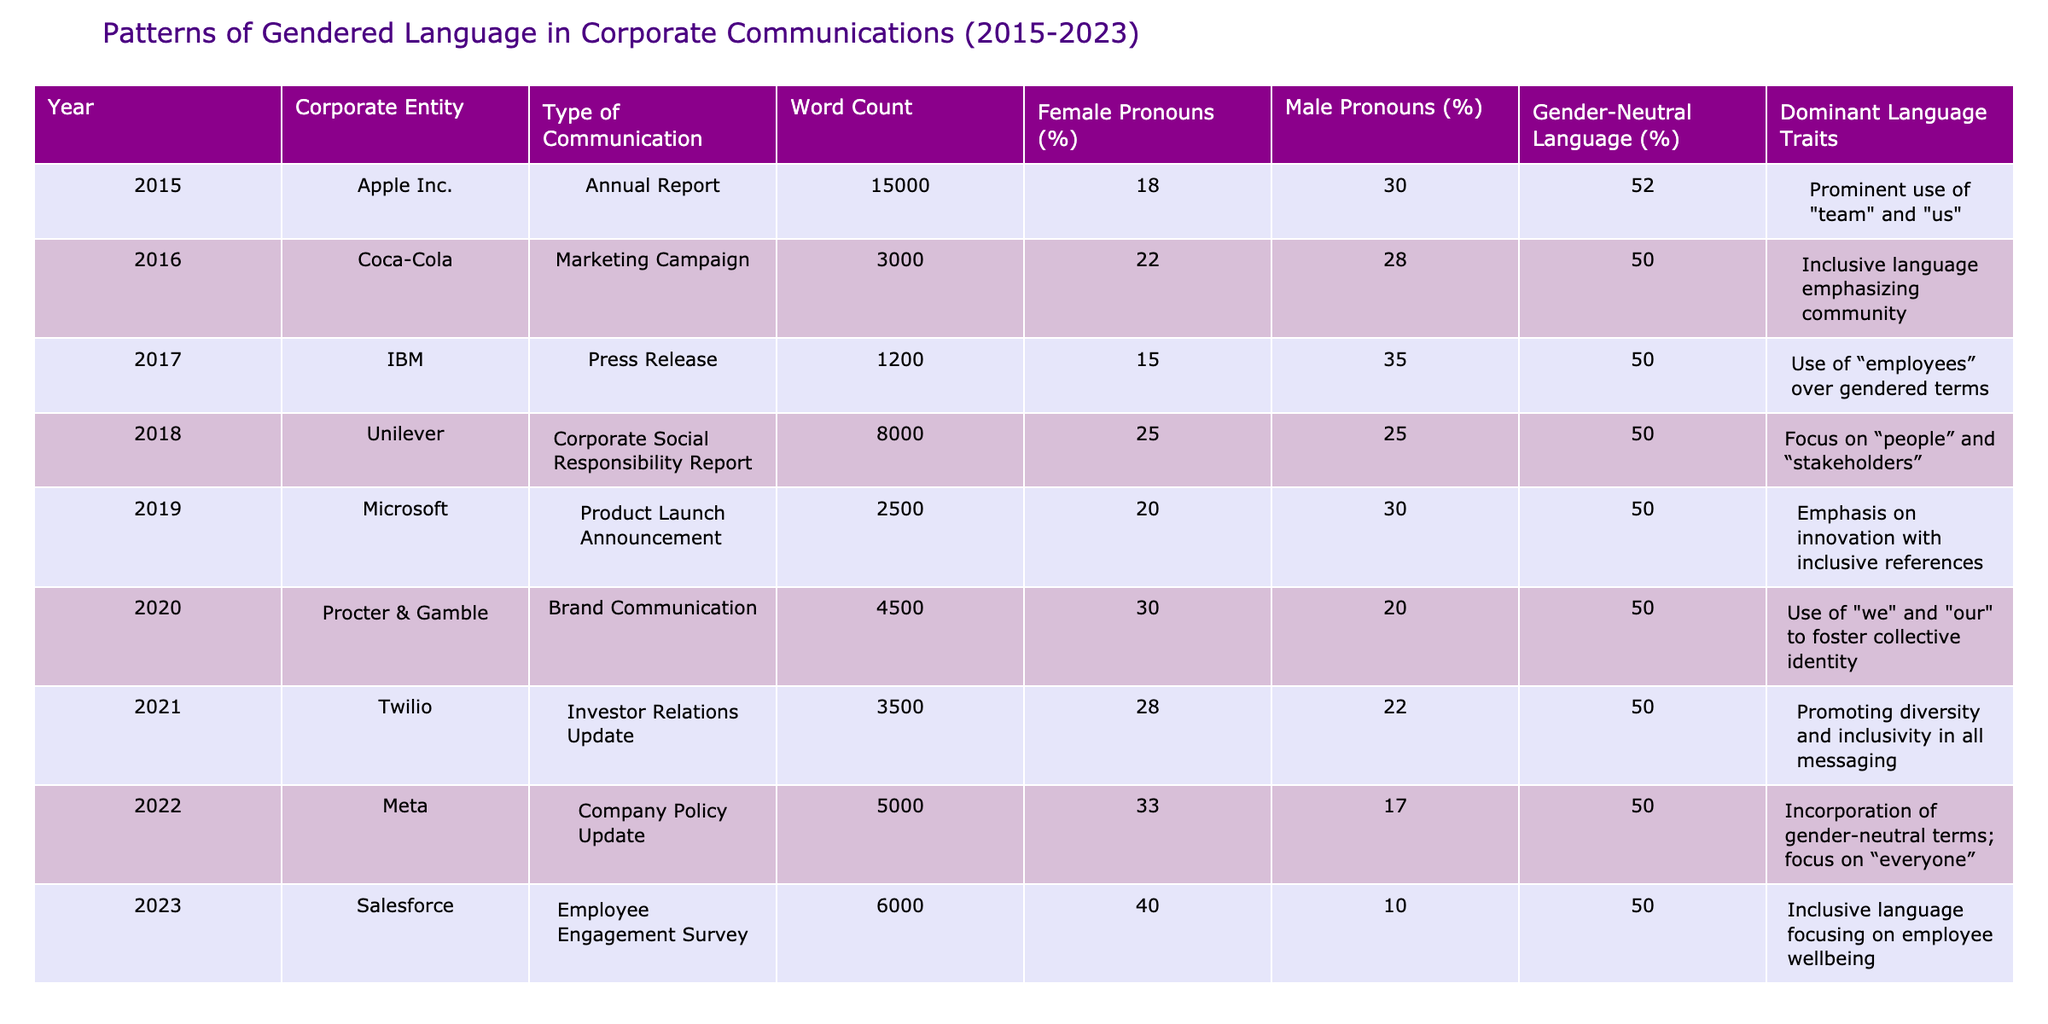What was the highest percentage of female pronouns used in a communication? Looking at the "Female Pronouns (%)" column, the highest value is 40% in 2023 for Salesforce.
Answer: 40% Which corporate entity had the lowest use of male pronouns? Checking the "Male Pronouns (%)" column, Meta in 2022 had the lowest value at 10%.
Answer: 10% What is the average percentage of gender-neutral language used across all years? Calculating the average from the "Gender-Neutral Language (%)" column: (52 + 50 + 50 + 50 + 50 + 50 + 50 + 50 + 50) = 450; dividing by 9 gives an average of 50%.
Answer: 50% In which year did Procter & Gamble use the most female pronouns, and what was that percentage? Procter & Gamble had 30% female pronouns in 2020, analyzed from the "Female Pronouns (%)" column for that year.
Answer: 30% in 2020 True or False: IBM had more use of male pronouns than female pronouns in 2017. By checking the values, IBM used 15% female pronouns and 35% male pronouns, which confirms the statement is true.
Answer: True What is the change in the percentage of female pronouns from 2015 to 2023? In 2015, the percentage was 18%, and in 2023, it was 40%. The change is 40% - 18% = 22%.
Answer: 22% increase Which year had the highest word count, and how does it compare to the lowest? The highest word count was in 2015 with 15,000 words, and the lowest was in 2017 with 1,200 words. The comparison is 15,000 - 1,200 = 13,800 more words.
Answer: 13,800 more words in 2015 What language traits were emphasized by Meta in 2022? The dominant language traits for Meta in 2022 included the incorporation of gender-neutral terms and a focus on “everyone.”
Answer: Incorporation of gender-neutral terms and a focus on “everyone” If we sum the percentages of male pronouns across the years, what is the total percentage? Summing the "Male Pronouns (%)": 30 + 28 + 35 + 25 + 30 + 20 + 22 + 17 + 10 =  217%.
Answer: 217% Which corporate entity showed the greatest improvement in the use of female pronouns from 2015 to 2023? Looking at the values, Salesforce in 2023 used 40% female pronouns compared to Apple’s 18% in 2015; this is an improvement of 22%.
Answer: Salesforce 